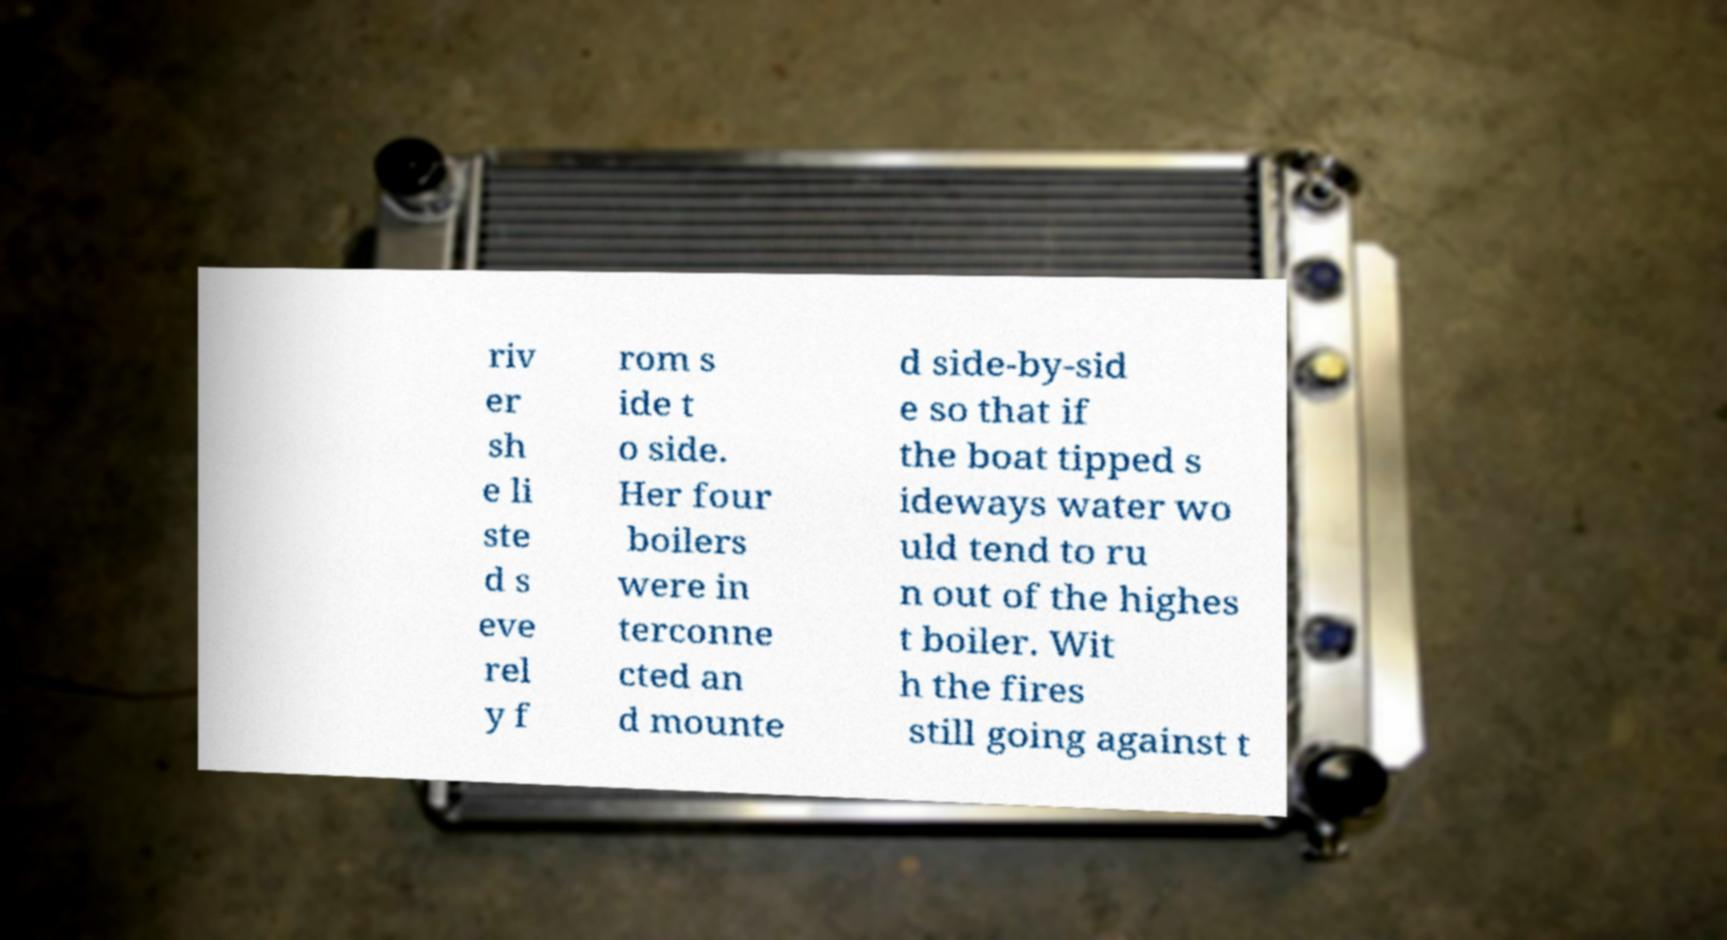There's text embedded in this image that I need extracted. Can you transcribe it verbatim? riv er sh e li ste d s eve rel y f rom s ide t o side. Her four boilers were in terconne cted an d mounte d side-by-sid e so that if the boat tipped s ideways water wo uld tend to ru n out of the highes t boiler. Wit h the fires still going against t 